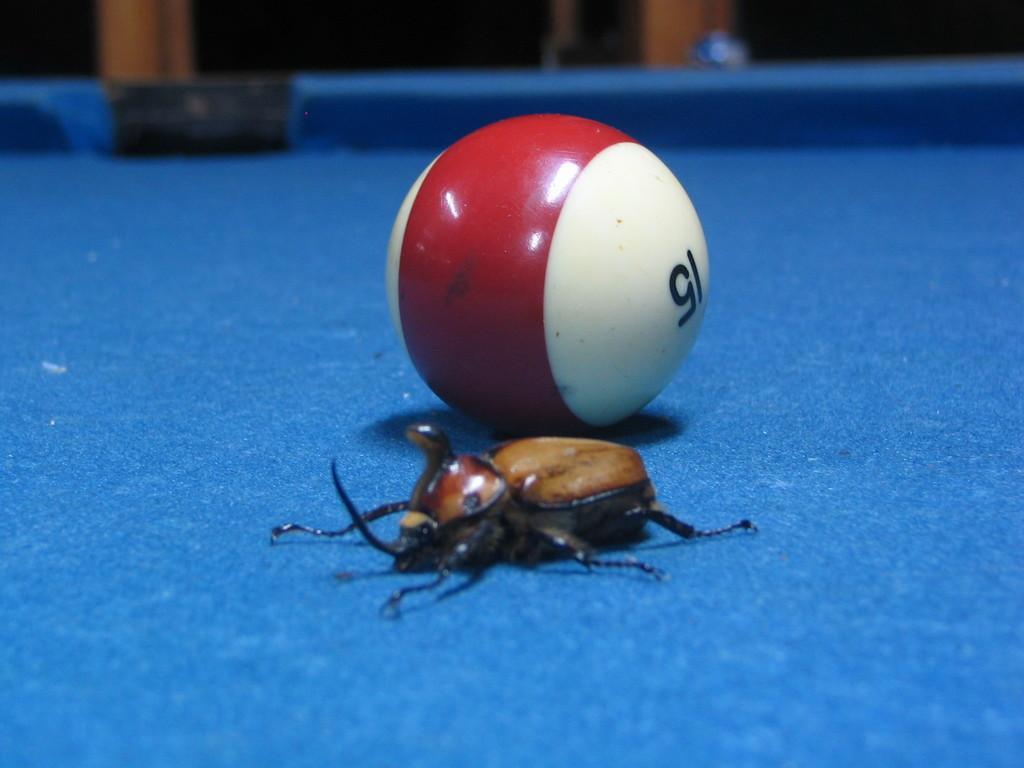Please provide a concise description of this image. In the image there is a blue surface with ball and a bug. 